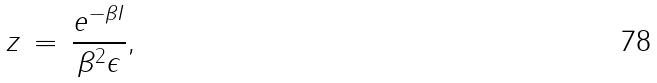<formula> <loc_0><loc_0><loc_500><loc_500>z \, = \, \frac { e ^ { - \beta I } } { \beta ^ { 2 } \epsilon } ,</formula> 